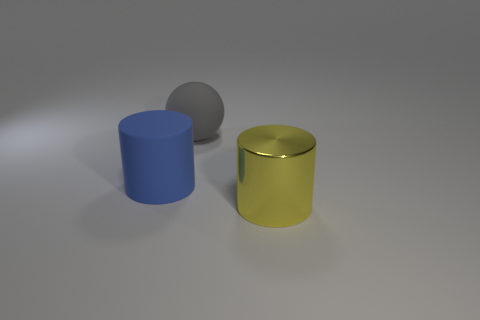Add 2 tiny red cylinders. How many objects exist? 5 Subtract all cylinders. How many objects are left? 1 Add 3 gray matte spheres. How many gray matte spheres are left? 4 Add 1 large blue shiny cylinders. How many large blue shiny cylinders exist? 1 Subtract 1 yellow cylinders. How many objects are left? 2 Subtract all rubber cylinders. Subtract all gray things. How many objects are left? 1 